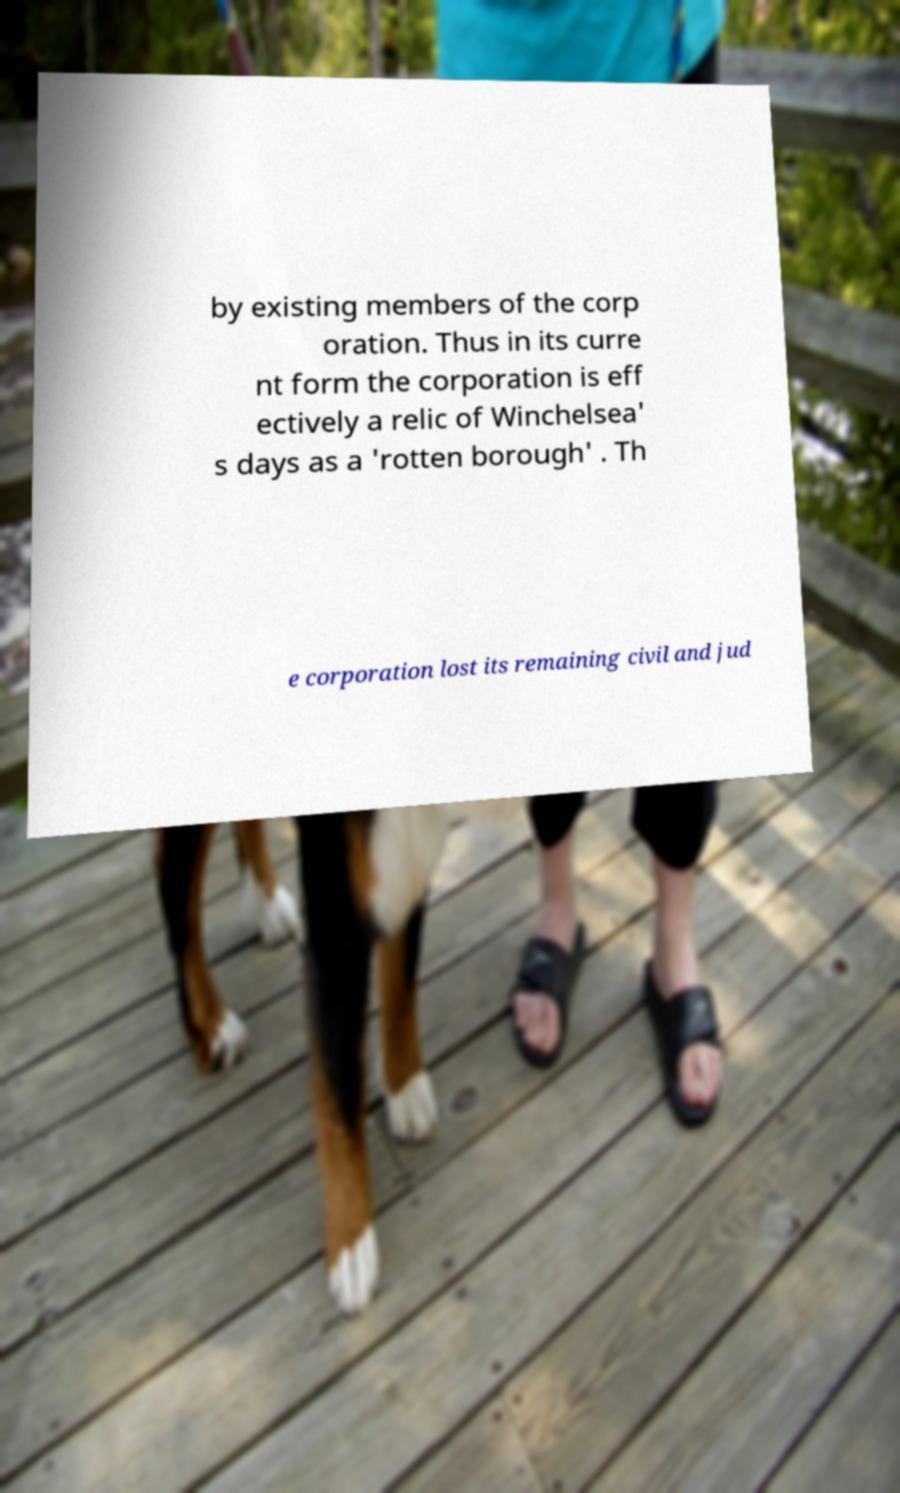There's text embedded in this image that I need extracted. Can you transcribe it verbatim? by existing members of the corp oration. Thus in its curre nt form the corporation is eff ectively a relic of Winchelsea' s days as a 'rotten borough' . Th e corporation lost its remaining civil and jud 